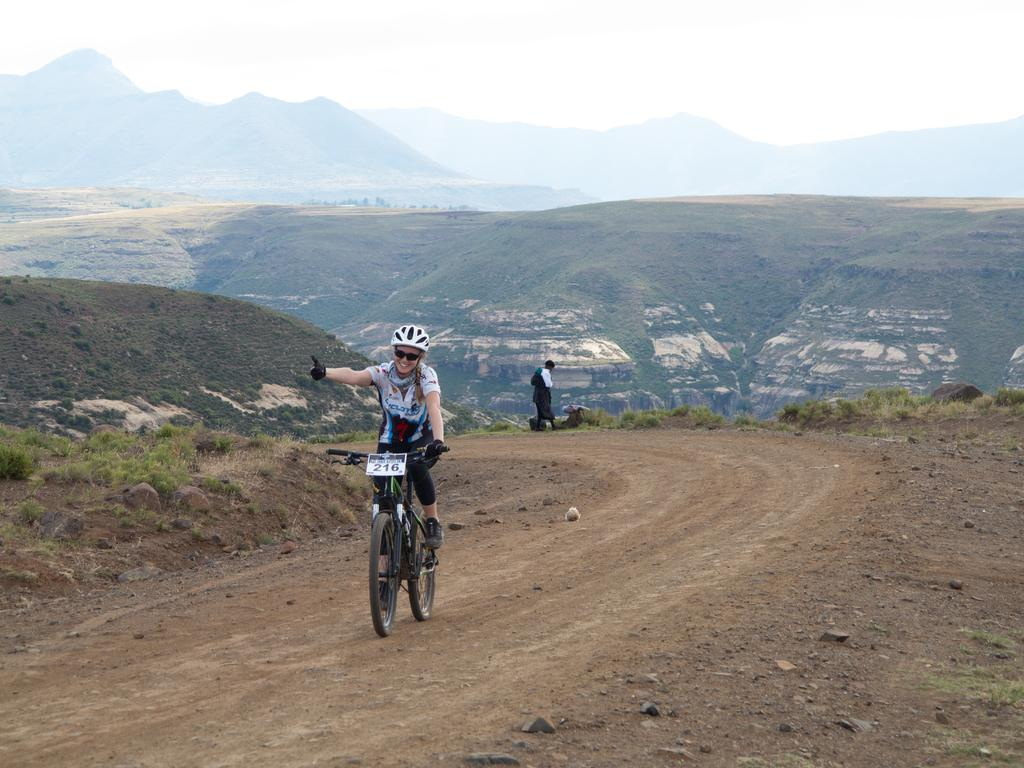What is the person in the image doing? The person is riding a bicycle in the image. Where is the bicycle located? The bicycle is on a road in the image. What can be seen around the road? The road is surrounded by greenery in the image. What type of landscape feature is visible in the distance? There are mountains visible in the image. How does the team participate in the earthquake depicted in the image? There is no team or earthquake present in the image; it features a person riding a bicycle on a road surrounded by greenery with mountains in the distance. 